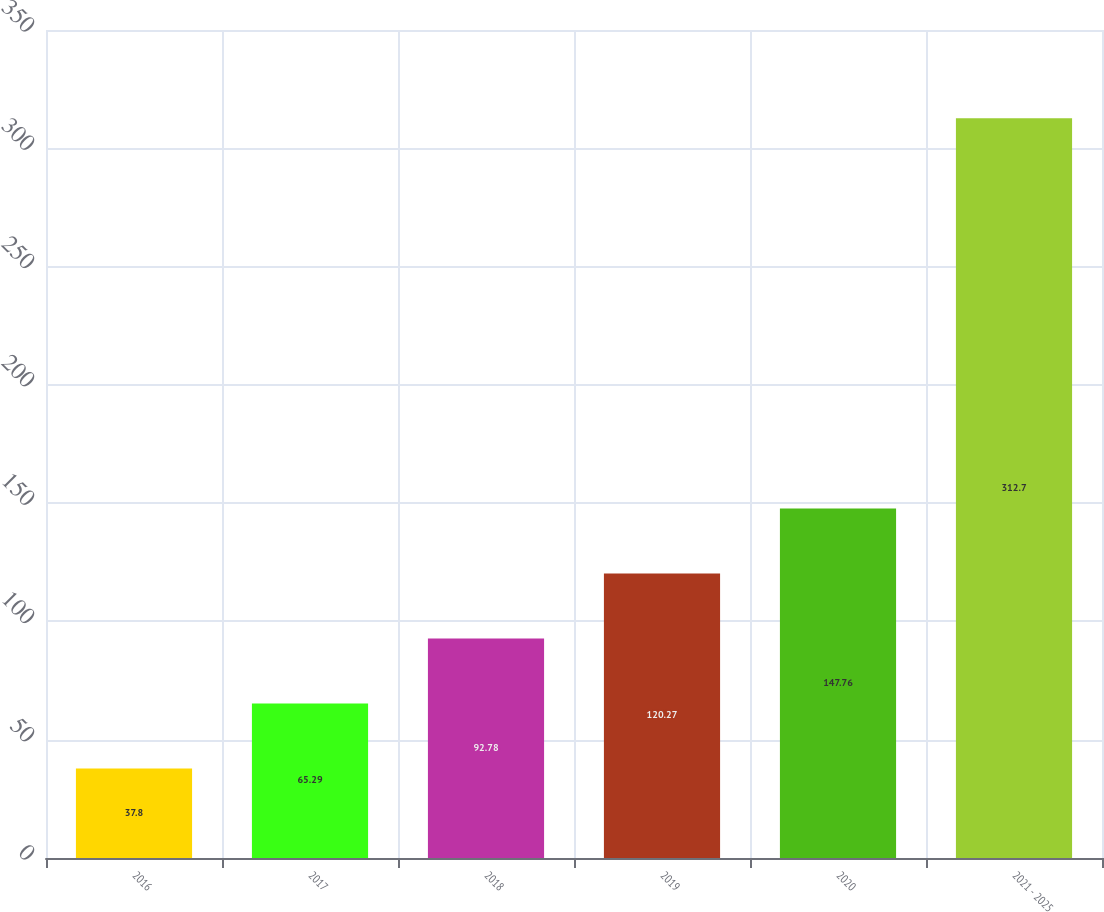<chart> <loc_0><loc_0><loc_500><loc_500><bar_chart><fcel>2016<fcel>2017<fcel>2018<fcel>2019<fcel>2020<fcel>2021 - 2025<nl><fcel>37.8<fcel>65.29<fcel>92.78<fcel>120.27<fcel>147.76<fcel>312.7<nl></chart> 